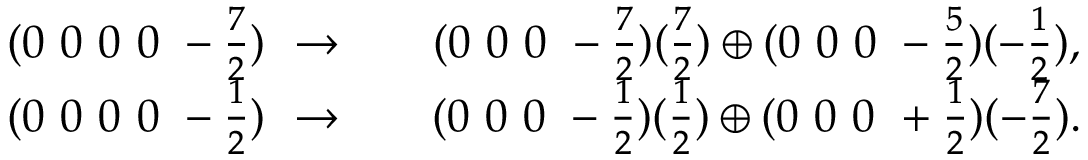Convert formula to latex. <formula><loc_0><loc_0><loc_500><loc_500>\begin{array} { c c c } { { ( 0 0 0 0 - \frac { 7 } { 2 } ) \rightarrow } } & { { ( 0 0 0 - \frac { 7 } { 2 } ) ( \frac { 7 } { 2 } ) \oplus ( 0 0 0 - \frac { 5 } { 2 } ) ( - \frac { 1 } { 2 } ) , } } \\ { { ( 0 0 0 0 - \frac { 1 } { 2 } ) \rightarrow } } & { { ( 0 0 0 - \frac { 1 } { 2 } ) ( \frac { 1 } { 2 } ) \oplus ( 0 0 0 + \frac { 1 } { 2 } ) ( - \frac { 7 } { 2 } ) . } } \end{array}</formula> 